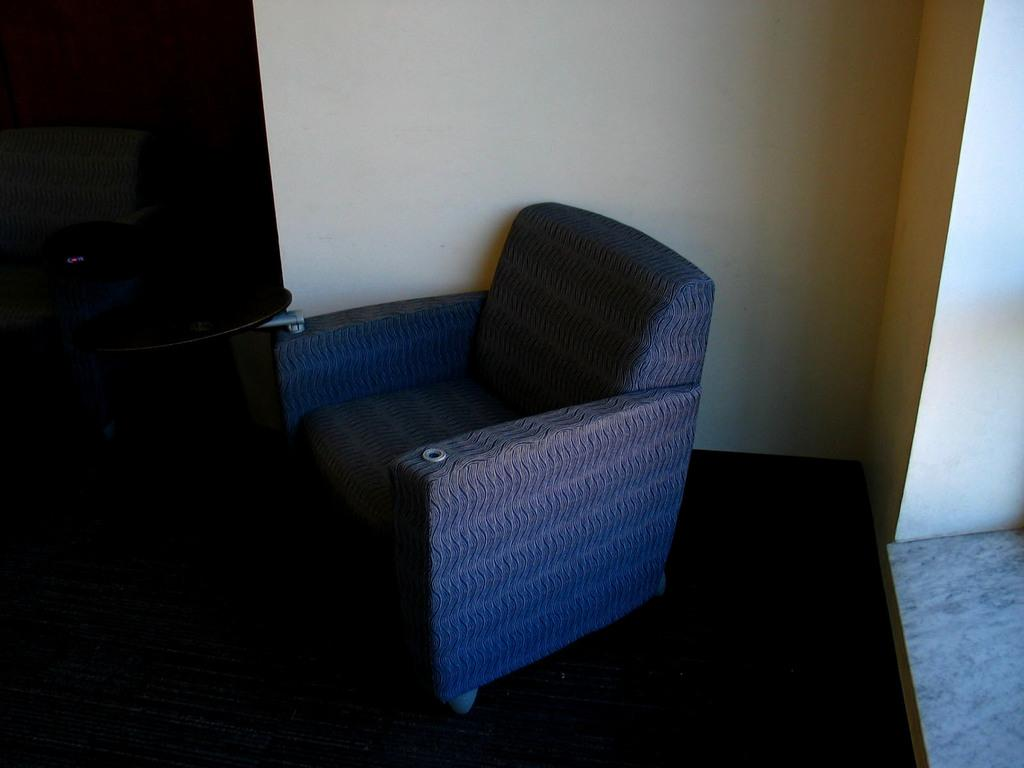What type of furniture is present in the image? There is a chair in the image. What can be used to enter or exit a room in the image? There is a door in the image. What type of structure is visible in the image? There is a wall in the image. What type of behavior does the kitty exhibit in the image? There is no kitty present in the image, so we cannot comment on its behavior. 